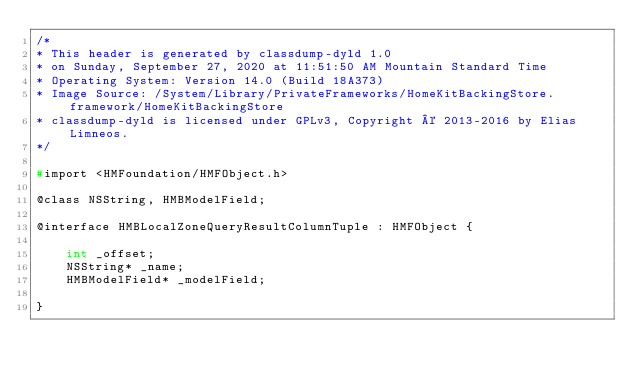Convert code to text. <code><loc_0><loc_0><loc_500><loc_500><_C_>/*
* This header is generated by classdump-dyld 1.0
* on Sunday, September 27, 2020 at 11:51:50 AM Mountain Standard Time
* Operating System: Version 14.0 (Build 18A373)
* Image Source: /System/Library/PrivateFrameworks/HomeKitBackingStore.framework/HomeKitBackingStore
* classdump-dyld is licensed under GPLv3, Copyright © 2013-2016 by Elias Limneos.
*/

#import <HMFoundation/HMFObject.h>

@class NSString, HMBModelField;

@interface HMBLocalZoneQueryResultColumnTuple : HMFObject {

	int _offset;
	NSString* _name;
	HMBModelField* _modelField;

}
</code> 